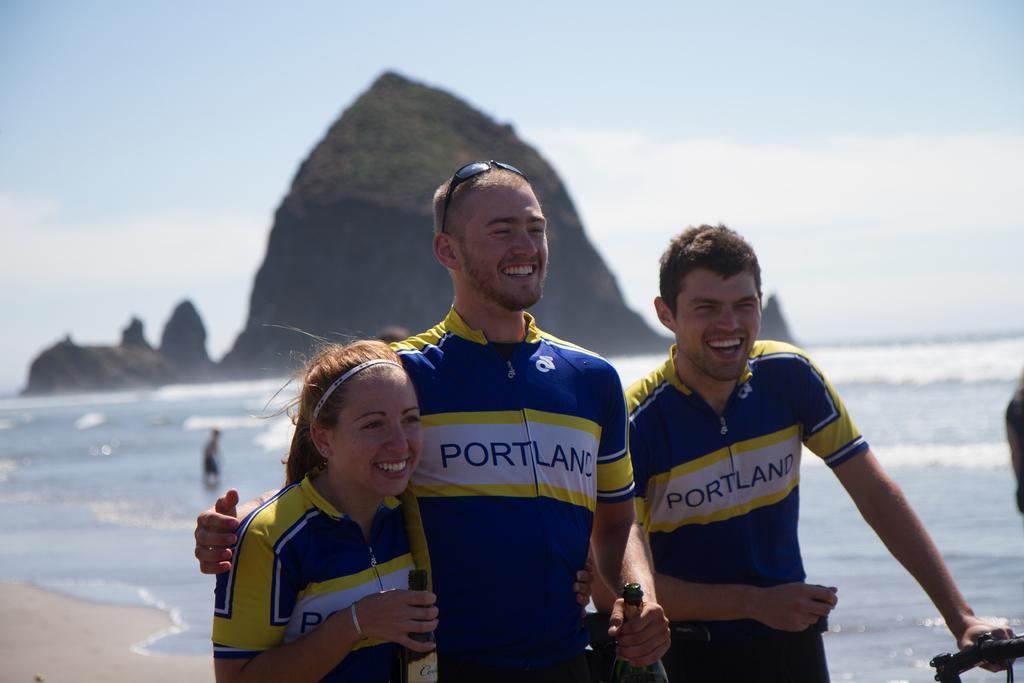<image>
Describe the image concisely. a man with the word Portland on his shirt 